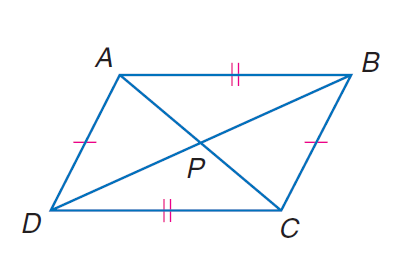Answer the mathemtical geometry problem and directly provide the correct option letter.
Question: In quadrilateral A B C D, A C = 188, B D = 214, m \angle B P C = 70, and P is the midpoint of A C and B D. Find the perimeter of quadrilateral A B C D.
Choices: A: 343.1 B: 423.1 C: 561.2 D: 671.2 C 